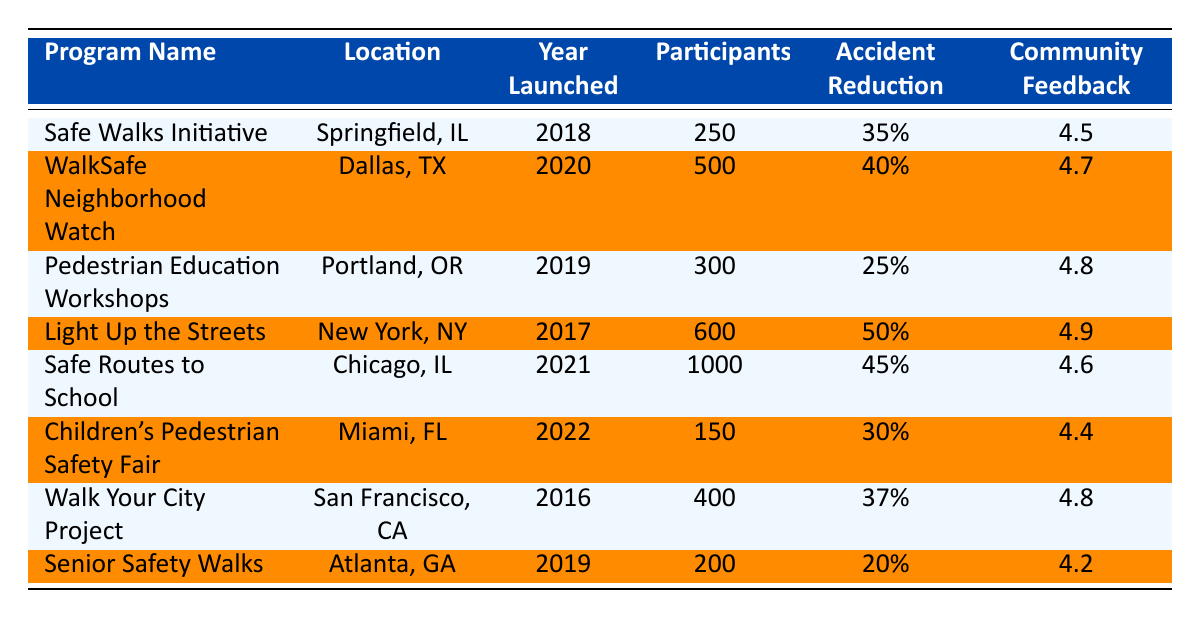What is the program with the highest accident reduction percentage? By scanning the accident reduction percentages, the program "Light Up the Streets" has the highest percentage at 50%.
Answer: Light Up the Streets How many participants were involved in the "Safe Routes to School"? The table lists the number of participants for each program. Here, "Safe Routes to School" has 1000 participants.
Answer: 1000 Which program has the lowest community feedback score? The community feedback scores show that "Senior Safety Walks" has the lowest score of 4.2 among all programs listed.
Answer: 4.2 Is there a follow-up program for the "WalkSafe Neighborhood Watch"? According to the table, the "WalkSafe Neighborhood Watch" does not have follow-up programs, as indicated by the "False" value in the respective column.
Answer: No What is the average accident reduction percentage of all programs listed? To find the average, sum all accident reduction percentages: (35 + 40 + 25 + 50 + 45 + 30 + 37 + 20) = 282. There are 8 programs, so the average is 282/8 = 35.25%.
Answer: 35.25% Which programs launched in or after 2020? The programs that launched in or after 2020 are "WalkSafe Neighborhood Watch" (2020), "Safe Routes to School" (2021), and "Children's Pedestrian Safety Fair" (2022).
Answer: WalkSafe Neighborhood Watch, Safe Routes to School, Children's Pedestrian Safety Fair Do all programs developed follow-up programs? From the table, not all programs have follow-up programs. The programs "WalkSafe Neighborhood Watch" and "Senior Safety Walks" do not have follow-up programs according to the data provided.
Answer: No What is the median community feedback score among the programs? First, list the feedback scores: 4.5, 4.7, 4.8, 4.9, 4.6, 4.4, 4.8, 4.2. When sorted, it yields: 4.2, 4.4, 4.5, 4.6, 4.7, 4.8, 4.8, 4.9. The median (average of 4.6 and 4.7) is (4.6 + 4.7) / 2 = 4.65.
Answer: 4.65 